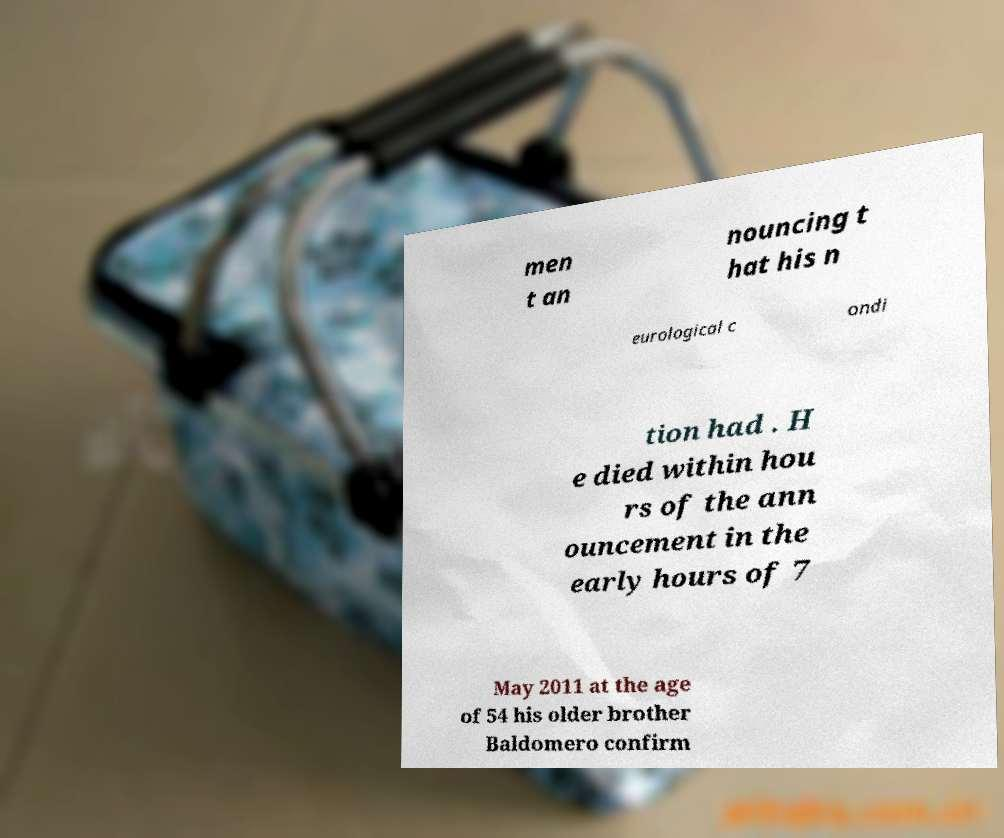Please read and relay the text visible in this image. What does it say? men t an nouncing t hat his n eurological c ondi tion had . H e died within hou rs of the ann ouncement in the early hours of 7 May 2011 at the age of 54 his older brother Baldomero confirm 